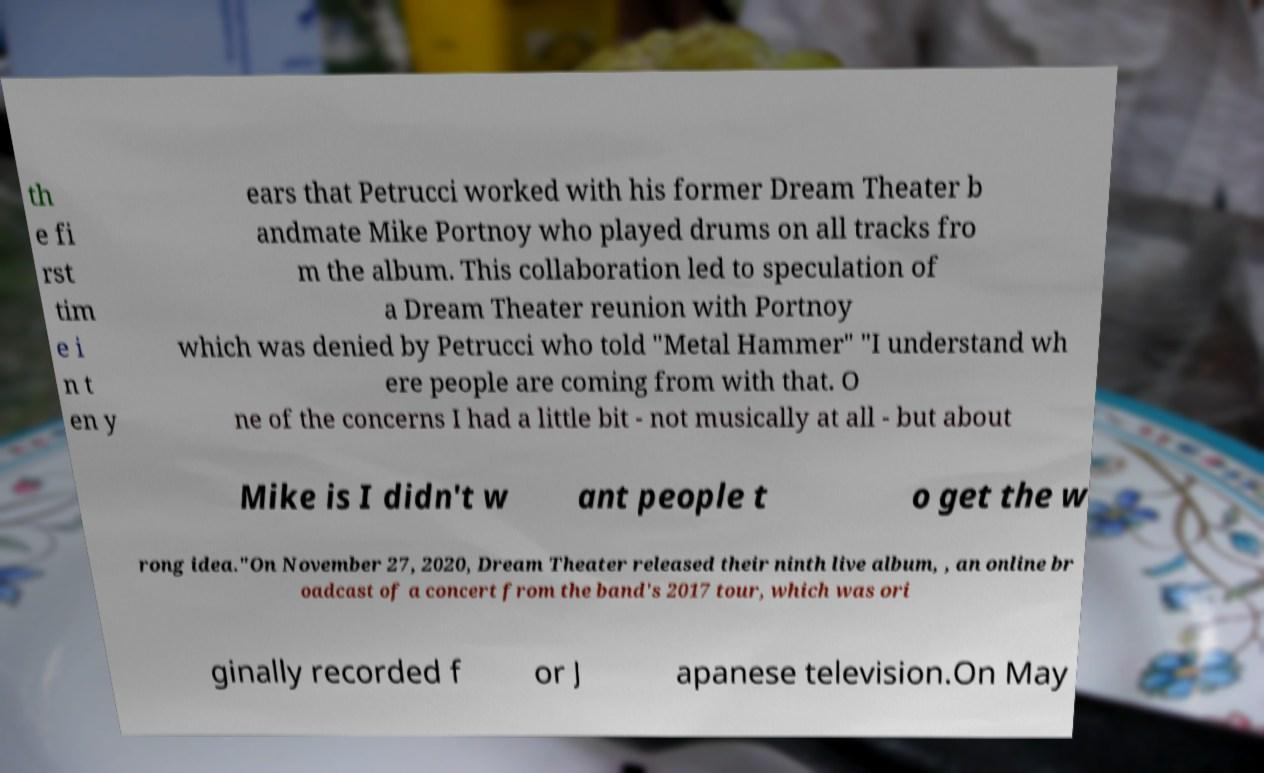Please read and relay the text visible in this image. What does it say? th e fi rst tim e i n t en y ears that Petrucci worked with his former Dream Theater b andmate Mike Portnoy who played drums on all tracks fro m the album. This collaboration led to speculation of a Dream Theater reunion with Portnoy which was denied by Petrucci who told "Metal Hammer" "I understand wh ere people are coming from with that. O ne of the concerns I had a little bit - not musically at all - but about Mike is I didn't w ant people t o get the w rong idea."On November 27, 2020, Dream Theater released their ninth live album, , an online br oadcast of a concert from the band's 2017 tour, which was ori ginally recorded f or J apanese television.On May 